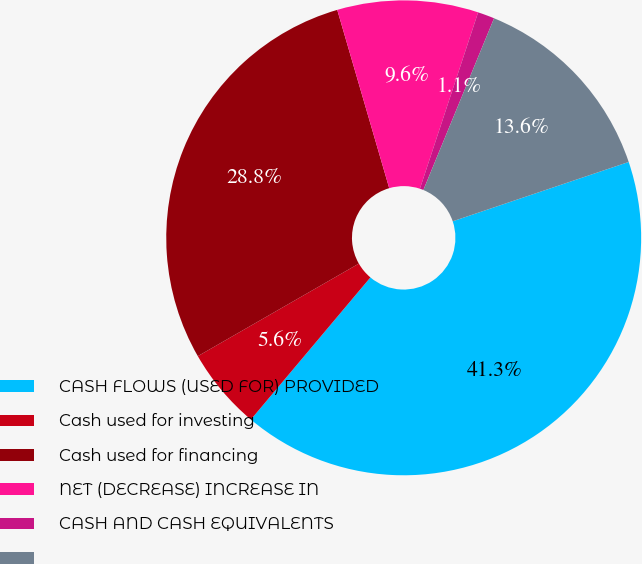Convert chart. <chart><loc_0><loc_0><loc_500><loc_500><pie_chart><fcel>CASH FLOWS (USED FOR) PROVIDED<fcel>Cash used for investing<fcel>Cash used for financing<fcel>NET (DECREASE) INCREASE IN<fcel>CASH AND CASH EQUIVALENTS<fcel>Unnamed: 5<nl><fcel>41.31%<fcel>5.57%<fcel>28.79%<fcel>9.59%<fcel>1.14%<fcel>13.61%<nl></chart> 